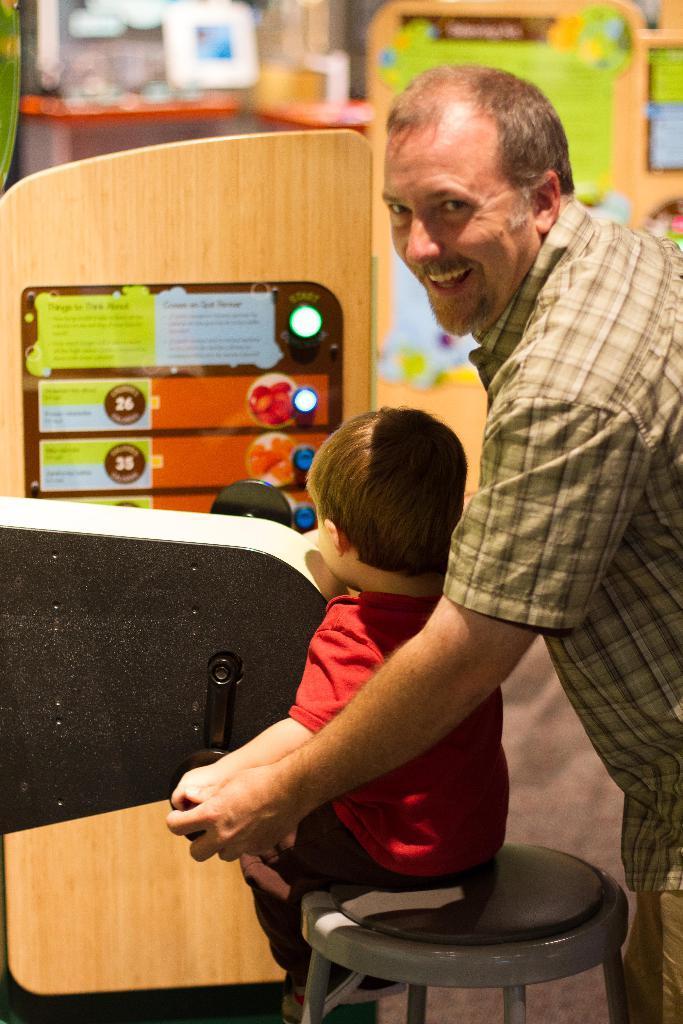In one or two sentences, can you explain what this image depicts? In this image I can see a person standing. There is a child sitting on the table. Also there are some objects in the background. 